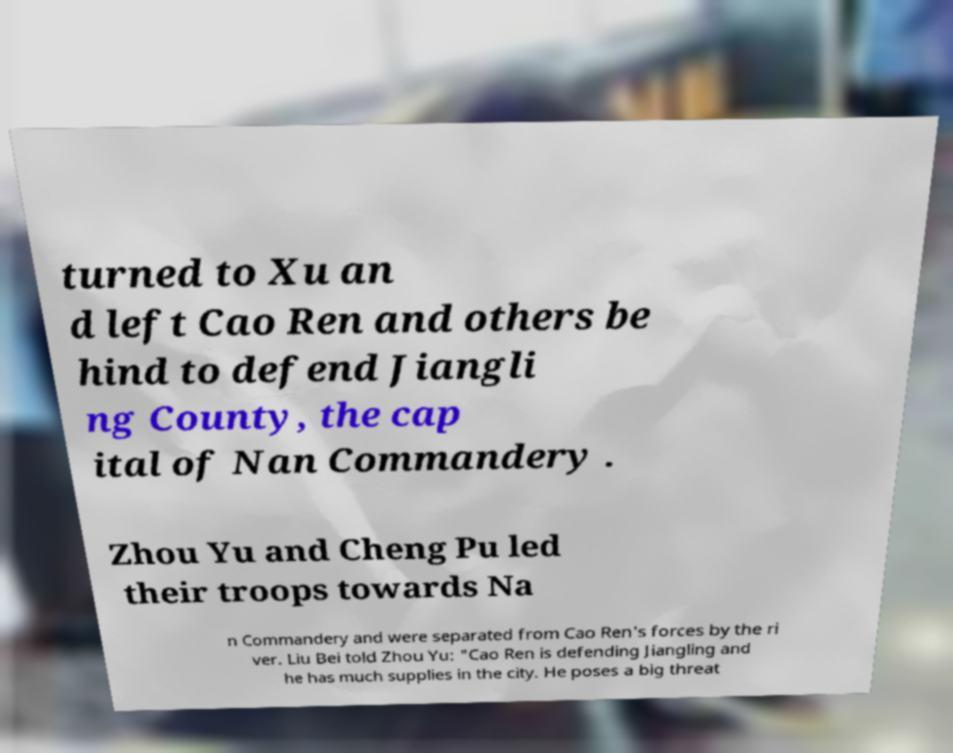Can you accurately transcribe the text from the provided image for me? turned to Xu an d left Cao Ren and others be hind to defend Jiangli ng County, the cap ital of Nan Commandery . Zhou Yu and Cheng Pu led their troops towards Na n Commandery and were separated from Cao Ren's forces by the ri ver. Liu Bei told Zhou Yu: "Cao Ren is defending Jiangling and he has much supplies in the city. He poses a big threat 